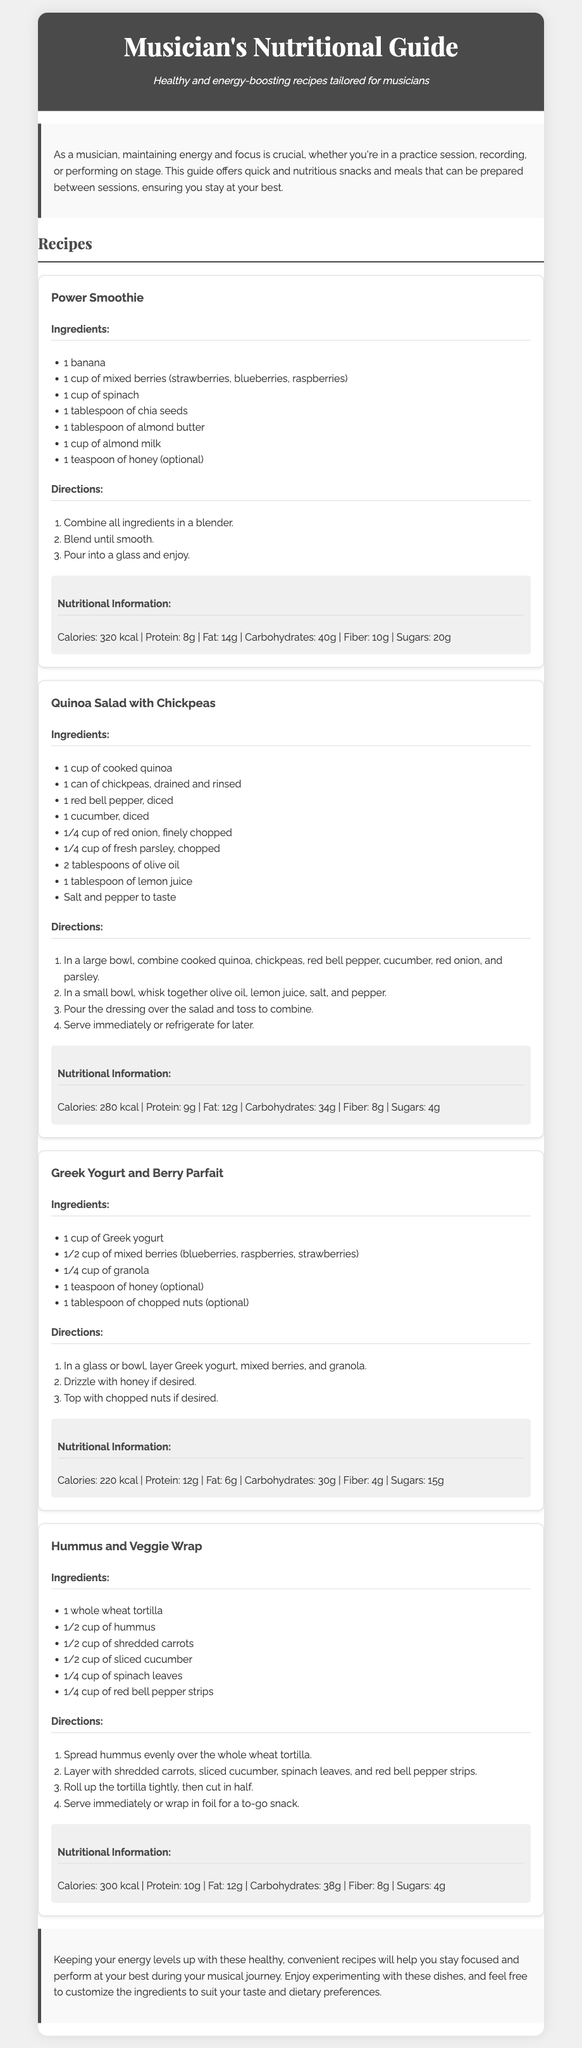what is the title of the guide? The title of the guide is found in the header section.
Answer: Musician's Nutritional Guide how many recipes are included in the document? The document lists four recipes under the Recipes section.
Answer: 4 what is the main ingredient in the Power Smoothie? The main ingredient can be found in the list of ingredients for the Power Smoothie recipe.
Answer: banana how many calories are in the Quinoa Salad with Chickpeas? The total calories can be found in the nutritional information for the Quinoa Salad with Chickpeas.
Answer: 280 kcal what type of tortilla is used in the Hummus and Veggie Wrap? The type of tortilla is explicitly mentioned in the ingredients list of the Hummus and Veggie Wrap recipe.
Answer: whole wheat tortilla which recipe has Greek yogurt as an ingredient? The recipe that includes Greek yogurt is listed first in the titles of the recipes.
Answer: Greek Yogurt and Berry Parfait what is the optional sweetener in the Power Smoothie? The optional sweetener is noted in the ingredients section of the Power Smoothie recipe.
Answer: honey what is the main purpose of the Nutritional Guide? The main purpose is stated in the introduction, explaining why these recipes are important for musicians.
Answer: maintain energy and focus 